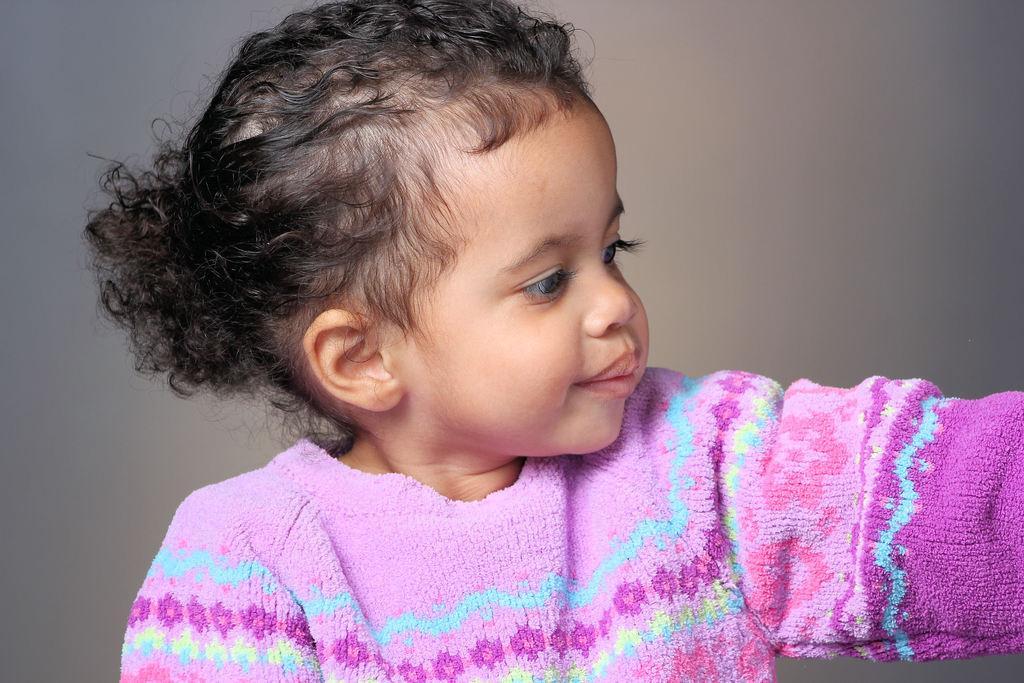Could you give a brief overview of what you see in this image? In this picture we can see a baby girl, and she wore a pink color dress. 